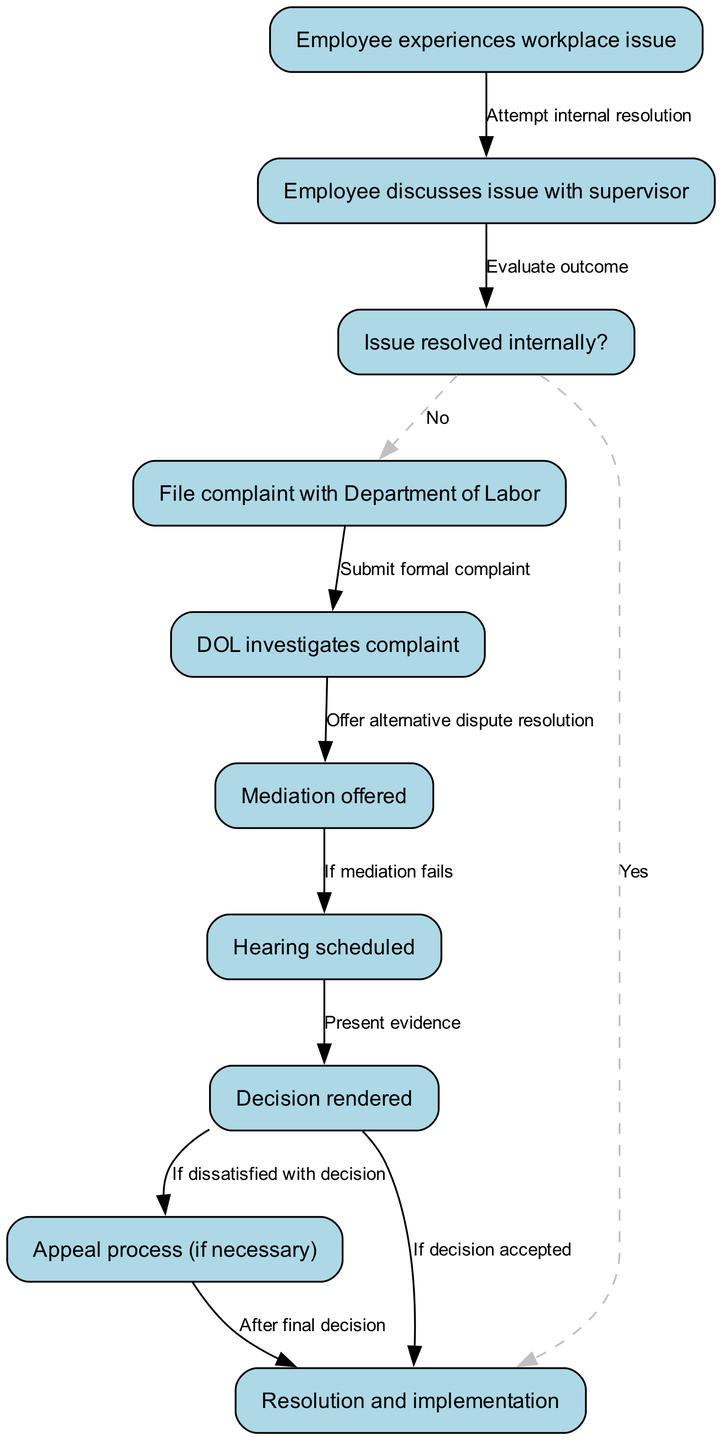What is the first step in the process? The first step in the process is represented by node 1, which states "Employee experiences workplace issue." This is the starting point of all subsequent actions in the flowchart.
Answer: Employee experiences workplace issue How many nodes are in the diagram? The diagram contains a total of 10 nodes representing different stages in the labor complaint process. Each node outlines a specific part of the process, which can be counted to determine the total number.
Answer: 10 What is the outcome if the issue is resolved internally? The diagram indicates that if the issue is resolved internally, as per the connection from node 3, the flow moves to node 10, which states "Resolution and implementation." This concludes the process positively without further action.
Answer: Resolution and implementation What happens after the Department of Labor investigates the complaint? After the Department of Labor investigates the complaint, represented by the transition from node 5 to node 6, mediation is offered as an alternative dispute resolution method. This is depicted in the flowchart and continues the resolution process.
Answer: Mediation offered What is the next step if mediation fails? If mediation fails, the flowchart indicates that the next step is to schedule a hearing, which is represented by the connection from node 6 to node 7. This step is crucial for further proceedings in the complaint process.
Answer: Hearing scheduled What is the final outcome if the decision rendered is accepted? If the decision rendered is accepted, as shown in the connection from node 8 to node 10, the final outcome is a resolution and implementation of that decision, which signifies the end of the process with an agreeable outcome.
Answer: Resolution and implementation How does an employee initiate the complaint process? An employee initiates the complaint process by experiencing a workplace issue, which is the first node in the flowchart. This step prompts them to take action by discussing the issue with their supervisor.
Answer: Employee experiences workplace issue What occurs if an employee is dissatisfied with the decision rendered? If an employee is dissatisfied with the decision rendered, the flowchart shows that they can enter the appeal process, leading from node 8 to node 9. This allows them to challenge the decision made.
Answer: Appeal process (if necessary) 